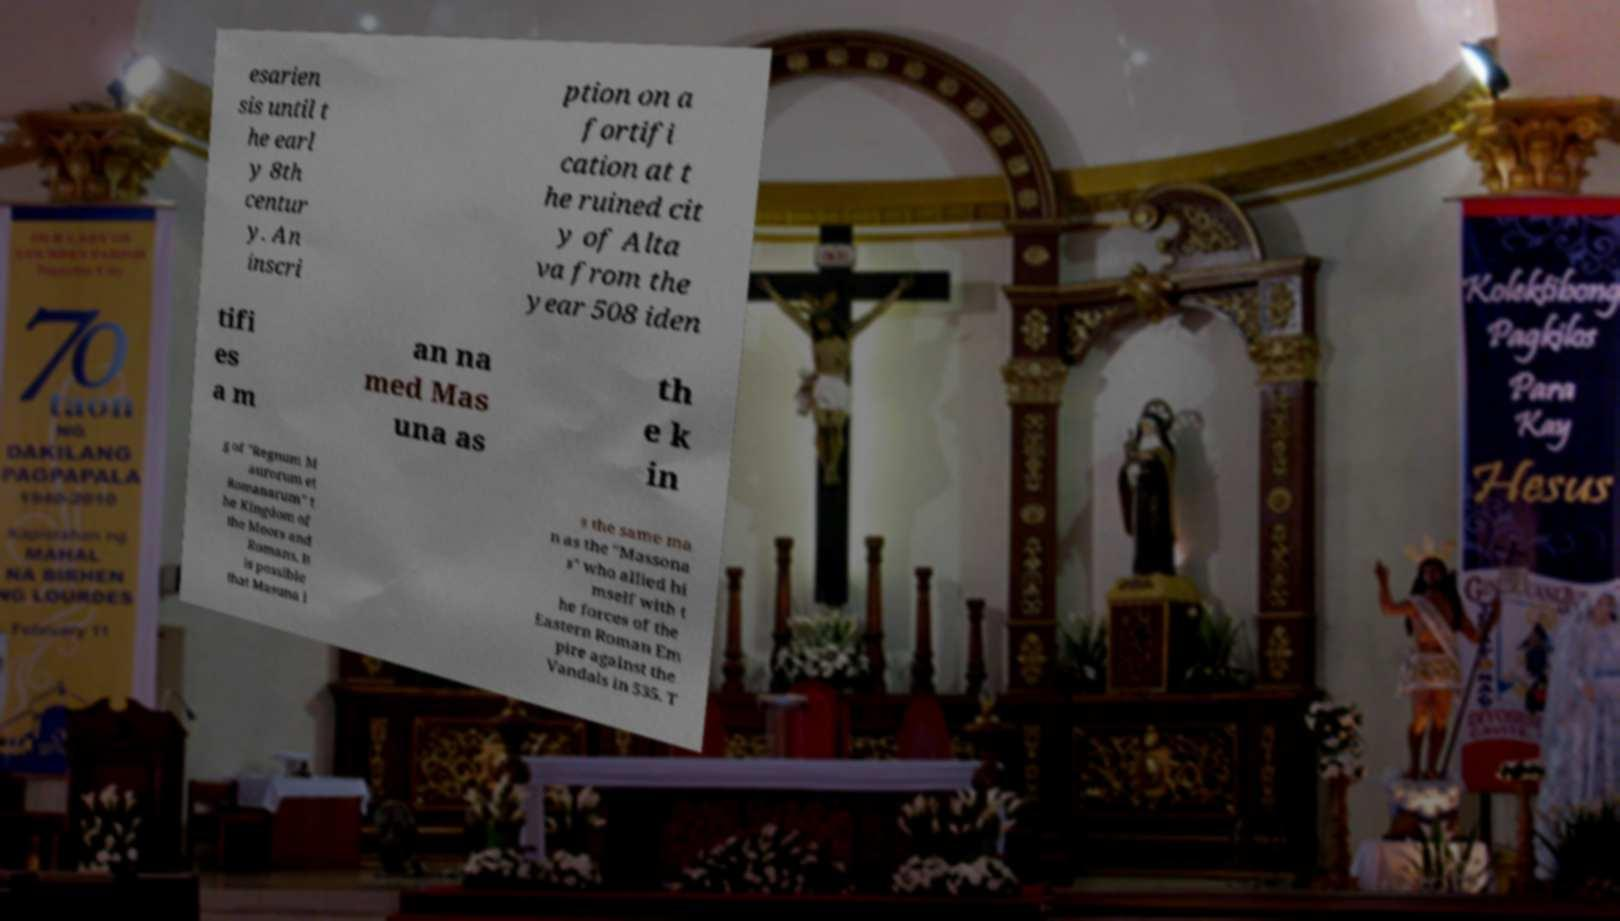I need the written content from this picture converted into text. Can you do that? esarien sis until t he earl y 8th centur y. An inscri ption on a fortifi cation at t he ruined cit y of Alta va from the year 508 iden tifi es a m an na med Mas una as th e k in g of "Regnum M aurorum et Romanarum" t he Kingdom of the Moors and Romans. It is possible that Masuna i s the same ma n as the "Massona s" who allied hi mself with t he forces of the Eastern Roman Em pire against the Vandals in 535. T 